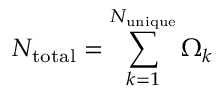Convert formula to latex. <formula><loc_0><loc_0><loc_500><loc_500>N _ { t o t a l } = \sum _ { k = 1 } ^ { N _ { u n i q u e } } \Omega _ { k }</formula> 